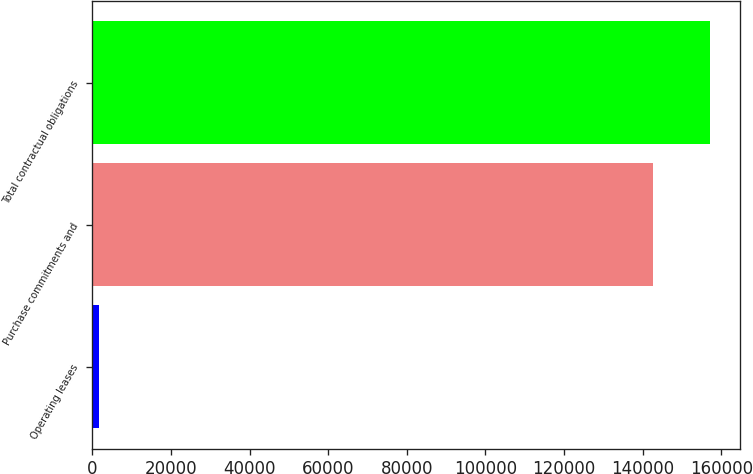Convert chart to OTSL. <chart><loc_0><loc_0><loc_500><loc_500><bar_chart><fcel>Operating leases<fcel>Purchase commitments and<fcel>Total contractual obligations<nl><fcel>1759<fcel>142714<fcel>156985<nl></chart> 